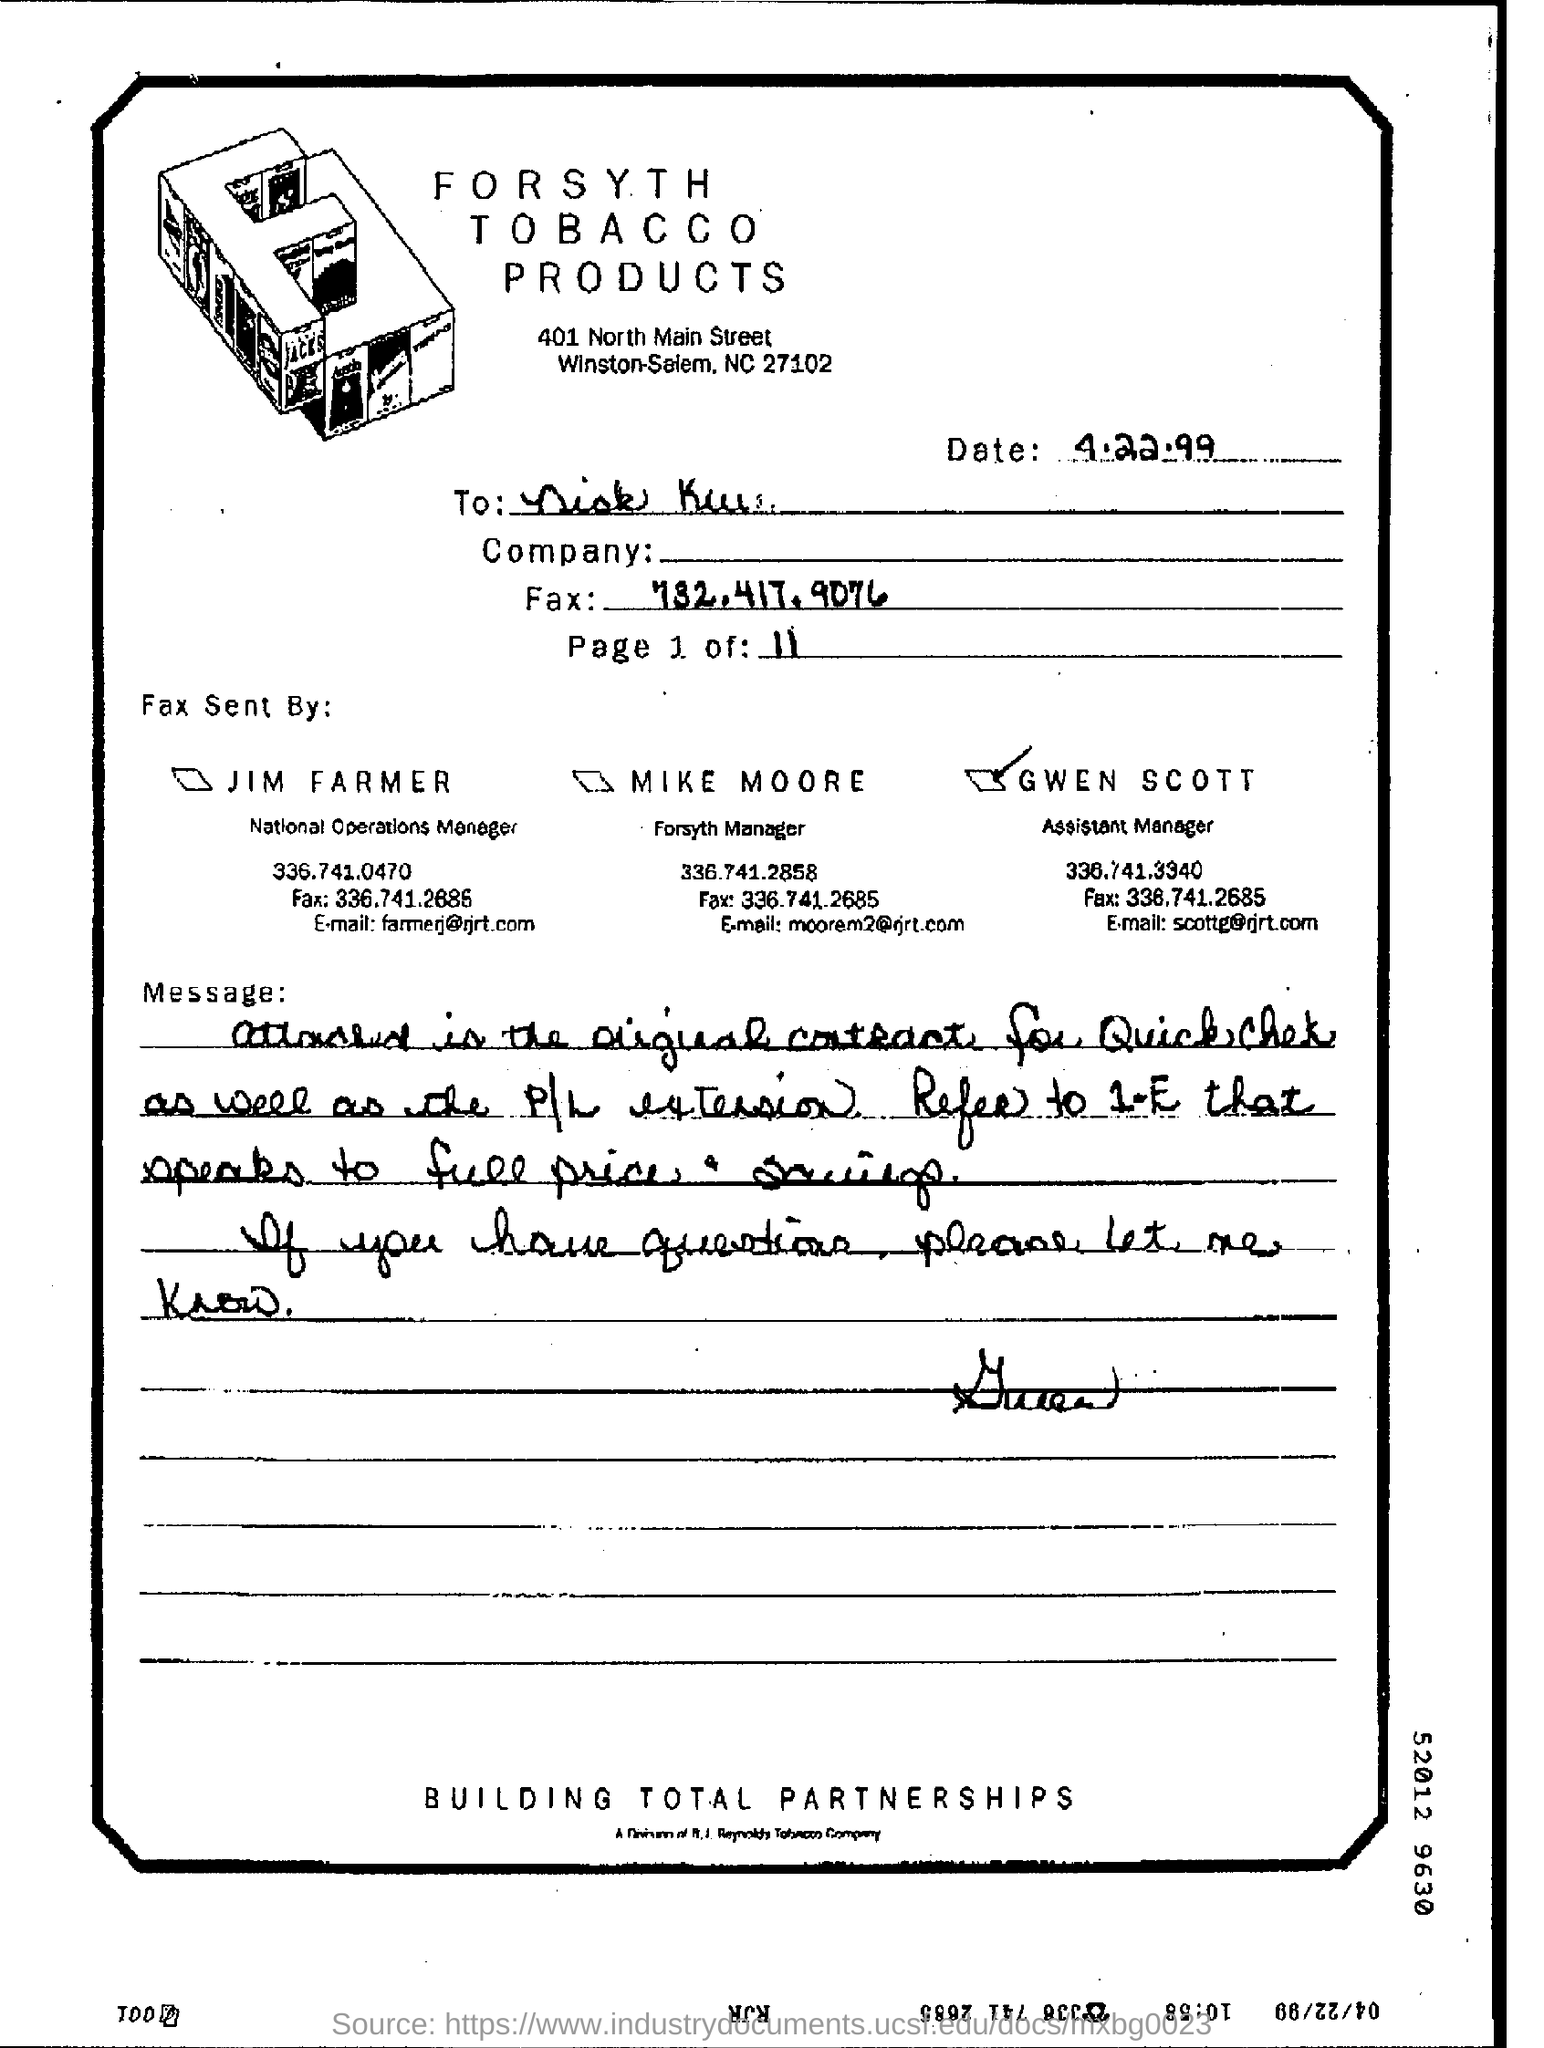What is the date mentioned in the top of the document ?
Your answer should be very brief. 4.22.99. 